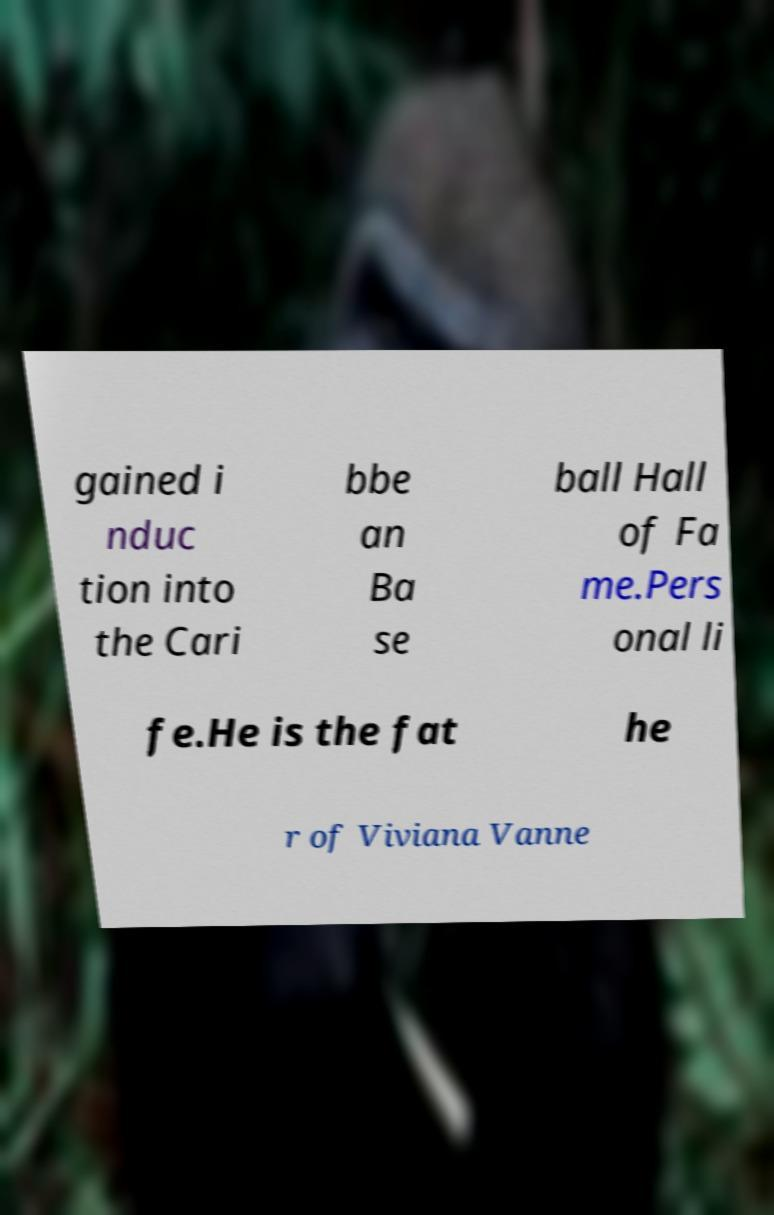Please read and relay the text visible in this image. What does it say? gained i nduc tion into the Cari bbe an Ba se ball Hall of Fa me.Pers onal li fe.He is the fat he r of Viviana Vanne 